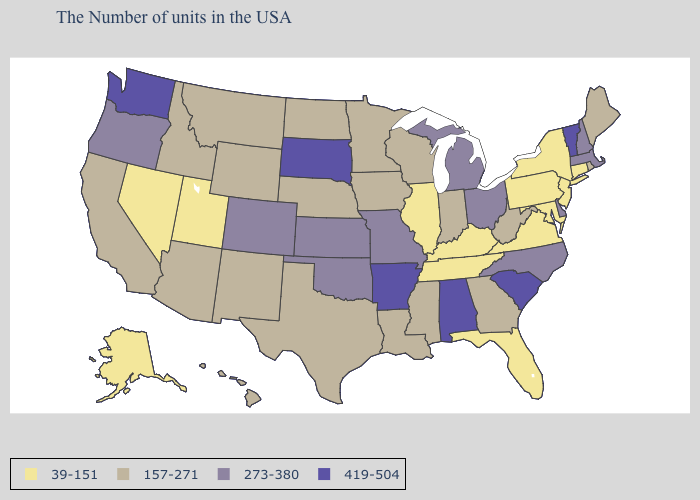Name the states that have a value in the range 39-151?
Give a very brief answer. Connecticut, New York, New Jersey, Maryland, Pennsylvania, Virginia, Florida, Kentucky, Tennessee, Illinois, Utah, Nevada, Alaska. What is the lowest value in states that border Mississippi?
Short answer required. 39-151. What is the value of New Jersey?
Give a very brief answer. 39-151. What is the highest value in the South ?
Short answer required. 419-504. Does Vermont have the highest value in the Northeast?
Be succinct. Yes. What is the highest value in states that border Alabama?
Write a very short answer. 157-271. What is the lowest value in states that border Mississippi?
Short answer required. 39-151. Does Oregon have the lowest value in the West?
Be succinct. No. Name the states that have a value in the range 157-271?
Quick response, please. Maine, Rhode Island, West Virginia, Georgia, Indiana, Wisconsin, Mississippi, Louisiana, Minnesota, Iowa, Nebraska, Texas, North Dakota, Wyoming, New Mexico, Montana, Arizona, Idaho, California, Hawaii. Does Connecticut have the lowest value in the Northeast?
Concise answer only. Yes. Does the map have missing data?
Write a very short answer. No. Which states have the highest value in the USA?
Give a very brief answer. Vermont, South Carolina, Alabama, Arkansas, South Dakota, Washington. Among the states that border Vermont , does New York have the lowest value?
Keep it brief. Yes. Does Iowa have the highest value in the MidWest?
Be succinct. No. 